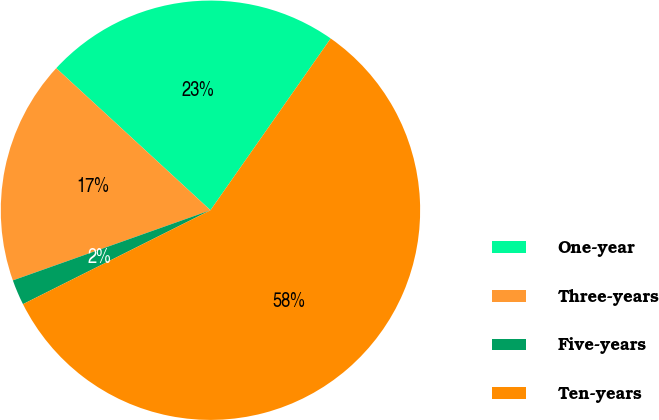Convert chart to OTSL. <chart><loc_0><loc_0><loc_500><loc_500><pie_chart><fcel>One-year<fcel>Three-years<fcel>Five-years<fcel>Ten-years<nl><fcel>22.87%<fcel>17.28%<fcel>1.96%<fcel>57.89%<nl></chart> 